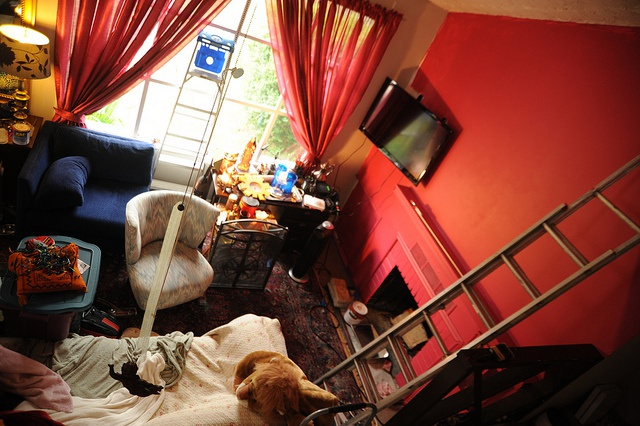Describe the objects in this image and their specific colors. I can see couch in black and tan tones, chair in black, navy, darkblue, and gray tones, bed in black, tan, and beige tones, chair in black, brown, gray, darkgray, and maroon tones, and tv in black, olive, maroon, and gray tones in this image. 